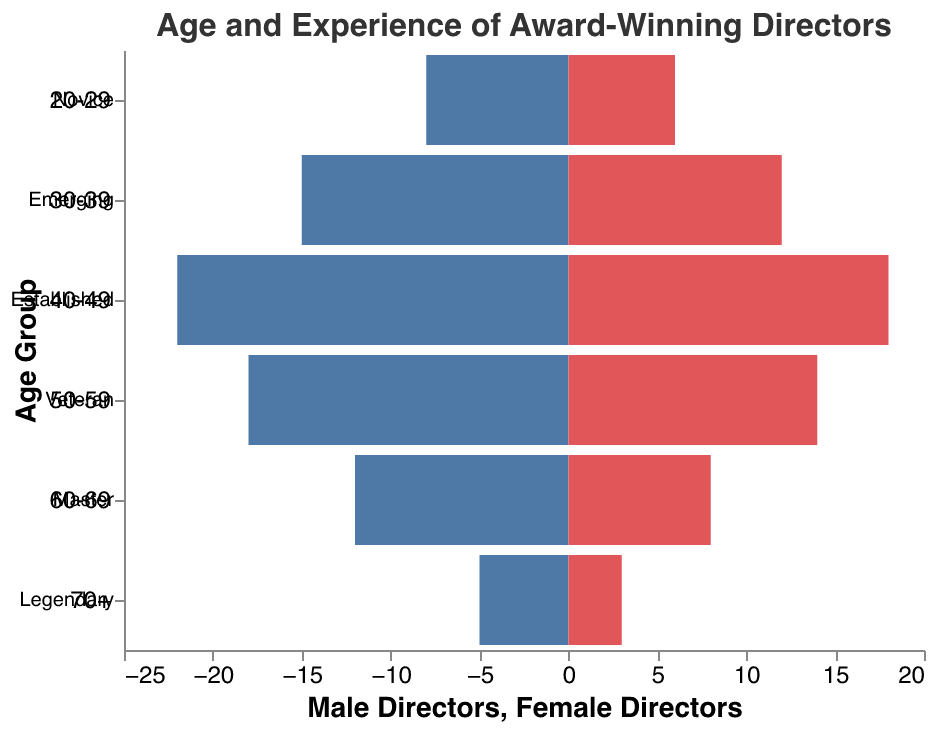What is the title of the figure? The title of the figure is displayed at the top of the plot, usually in a larger and bold font for better visibility.
Answer: Age and Experience of Award-Winning Directors How many male novice directors are there in the age group 20-29? Look at the bar for male directors in the 20-29 age group and observe the numerical value presented.
Answer: 8 Which age group has the highest number of female directors? Compare the lengths of bars representing female directors across all age groups and identify the longest one.
Answer: 40-49 What is the total number of award-winning directors in the age group 30-39? Sum the number of male and female directors in the 30-39 age group: 15 (male) + 12 (female) = 27
Answer: 27 How many legendary male directors are there? Look at the bar for male directors in the 70+ age group and observe the numerical value presented.
Answer: 5 How many more male directors than female directors are there in the 50-59 age group? Subtract the number of female directors from the number of male directors in the 50-59 age group: 18 (male) - 14 (female) = 4
Answer: 4 In which age group do you find an equal number of male and female directors? Compare the number of male and female directors in each age group to identify where the values match.
Answer: None What is the average number of male directors in the 20-29 and 30-39 age groups? Add the number of male directors in the 20-29 and 30-39 age groups and divide by 2: (8 (20-29) + 15 (30-39)) / 2 = 11.5
Answer: 11.5 How does the number of female veteran directors compare to the number of female novice directors? Compare the bars for female directors in the veteran (50-59) and novice (20-29) age groups to see which is longer: 14 (veteran) vs. 6 (novice)
Answer: Veteran directors 8 more Which gender has more award-winning directors overall in all age groups combined? Sum up the total number of male and female directors across all age groups and compare the two sums: 
Male - 8+15+22+18+12+5 = 80, 
Female - 6+12+18+14+8+3 = 61
Answer: Male directors 